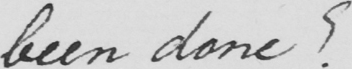Please provide the text content of this handwritten line. been done ? 